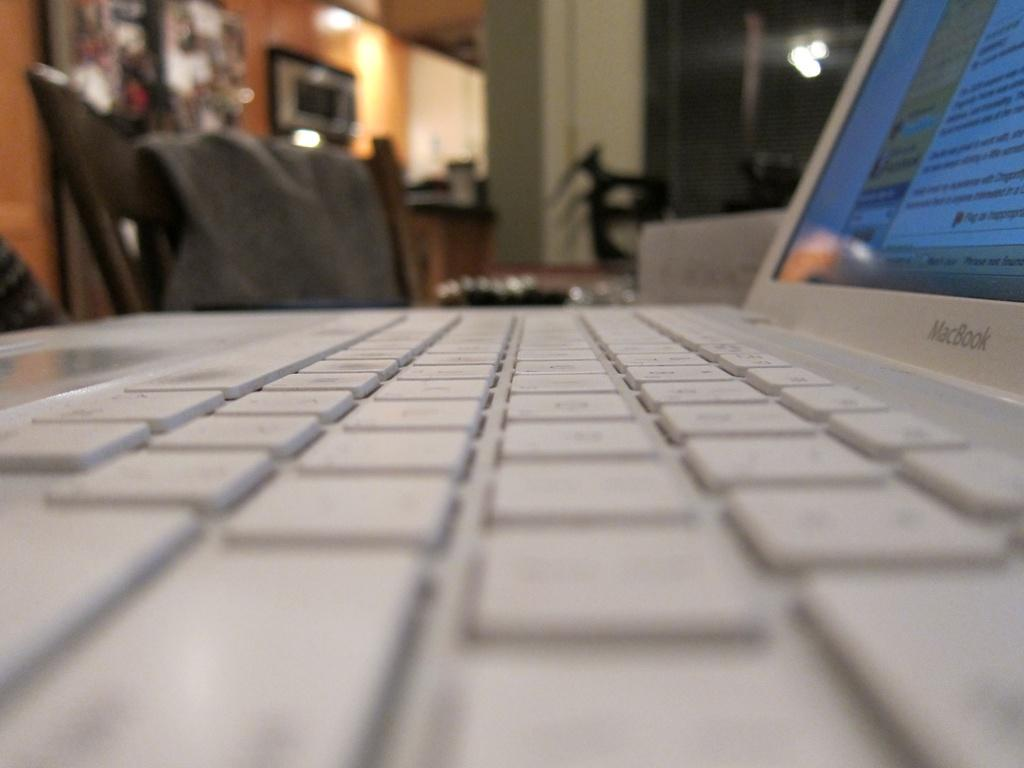What electronic device is visible in the image? There is a laptop in the image. What type of furniture is present in the image? There is a chair in the image. What architectural feature can be seen in the background of the image? There is a wall visible in the image. What allows natural light to enter the room in the image? There is a window in the image. What type of popcorn is being exchanged through the window in the image? There is no popcorn or exchange of any kind visible in the image. 